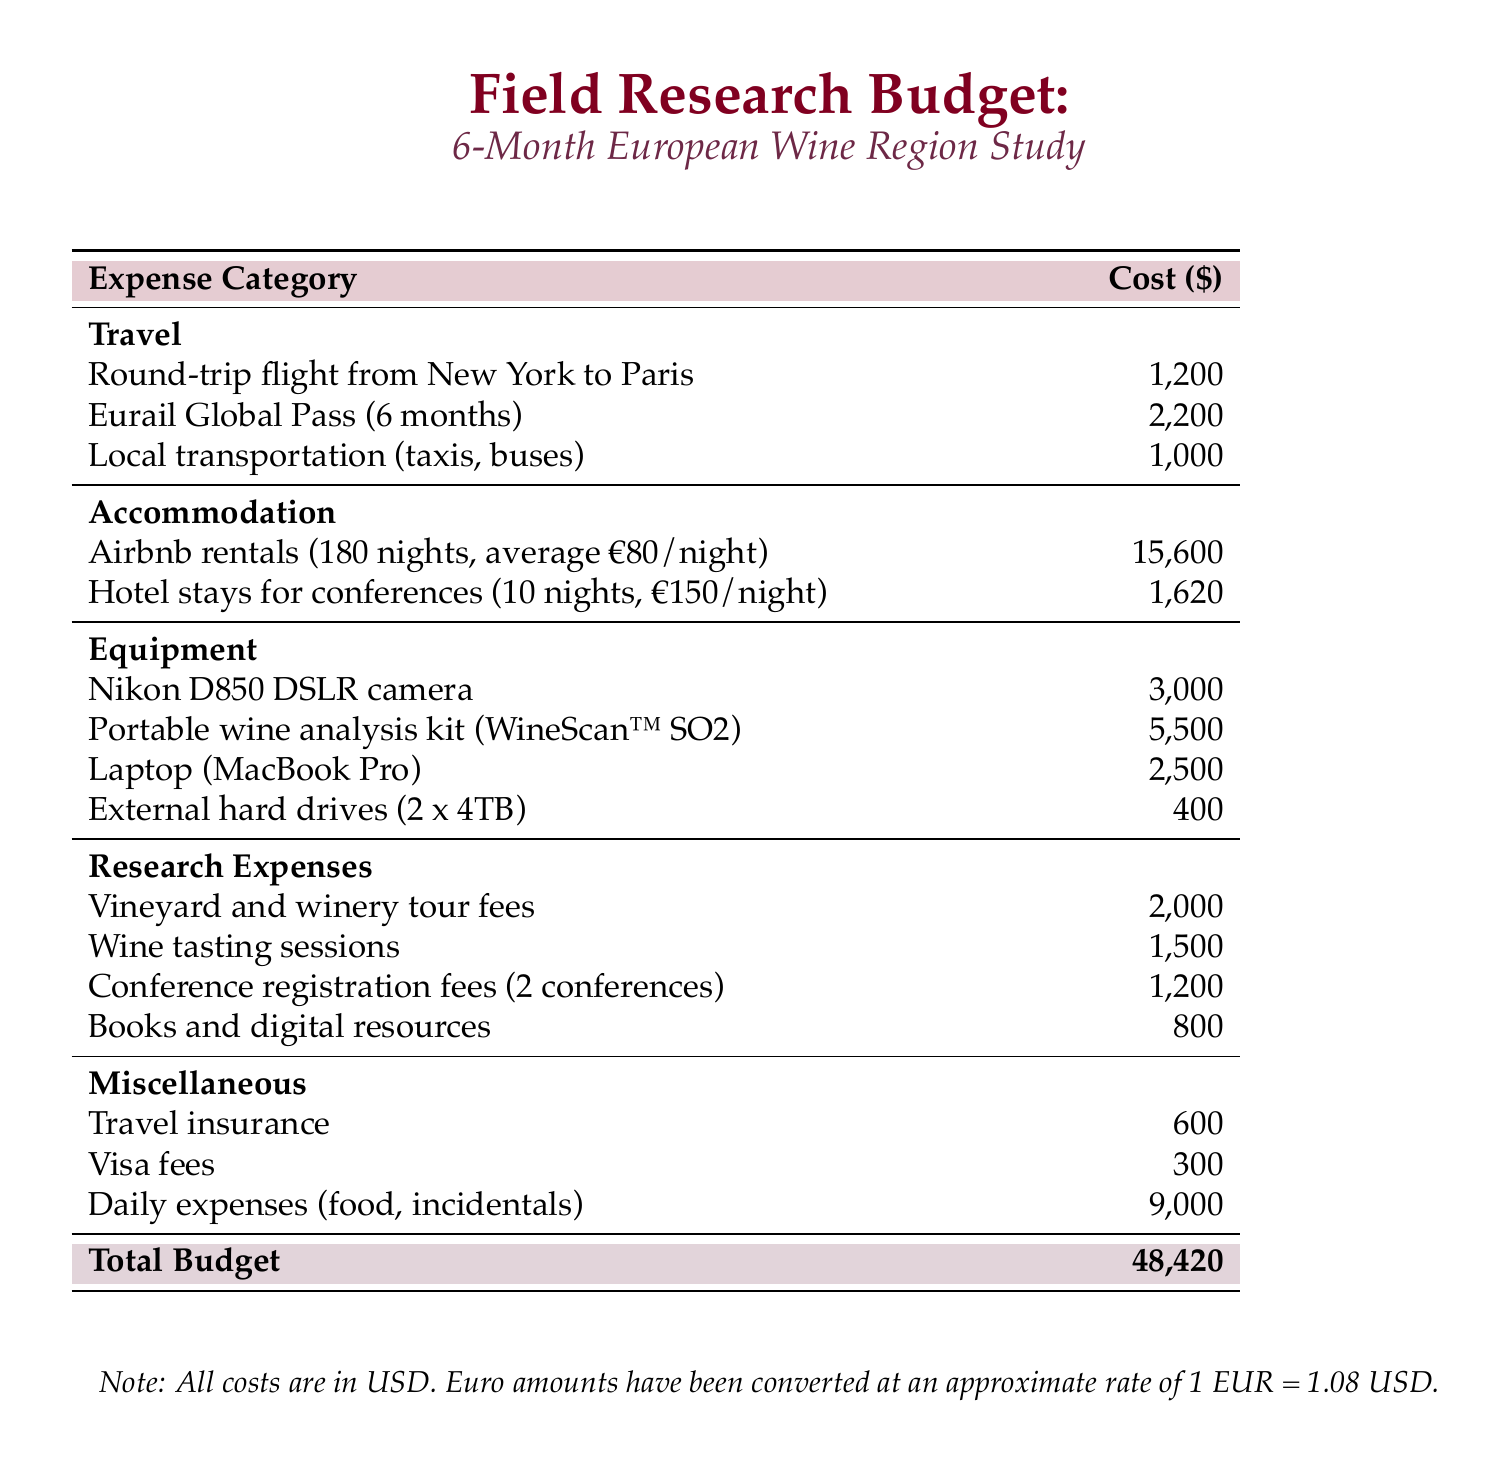What is the total budget for the research trip? The total budget is listed at the bottom of the document, summing up all expenses.
Answer: 48,420 What is the cost of Airbnb rentals? It is specified under the accommodation section, detailing the cost for 180 nights at an average of €80/night.
Answer: 15,600 How much does the Eurail Global Pass cost? The cost is provided in the travel section of the budget document.
Answer: 2,200 What is the cost for the Nikon D850 DSLR camera? It is listed under the equipment section as an individual item cost.
Answer: 3,000 How many days are covered by local transportation expenses? This is part of the travel section which outlines the budget for local transport without specifying the number of days. Reasoning is not required here since we refer directly to the cost.
Answer: 1,000 What are the daily expenses budgeted for food and incidentals? This is specified in the miscellaneous section of the document.
Answer: 9,000 How many conferences will the researcher register for? The number of conferences is stated in the research expenses section.
Answer: 2 What is the total cost of the portable wine analysis kit? This is indicated in the equipment section as a standalone cost.
Answer: 5,500 What is the visa fee included in the miscellaneous section? This cost is explicitly listed in the miscellaneous expenses towards the end of the document.
Answer: 300 